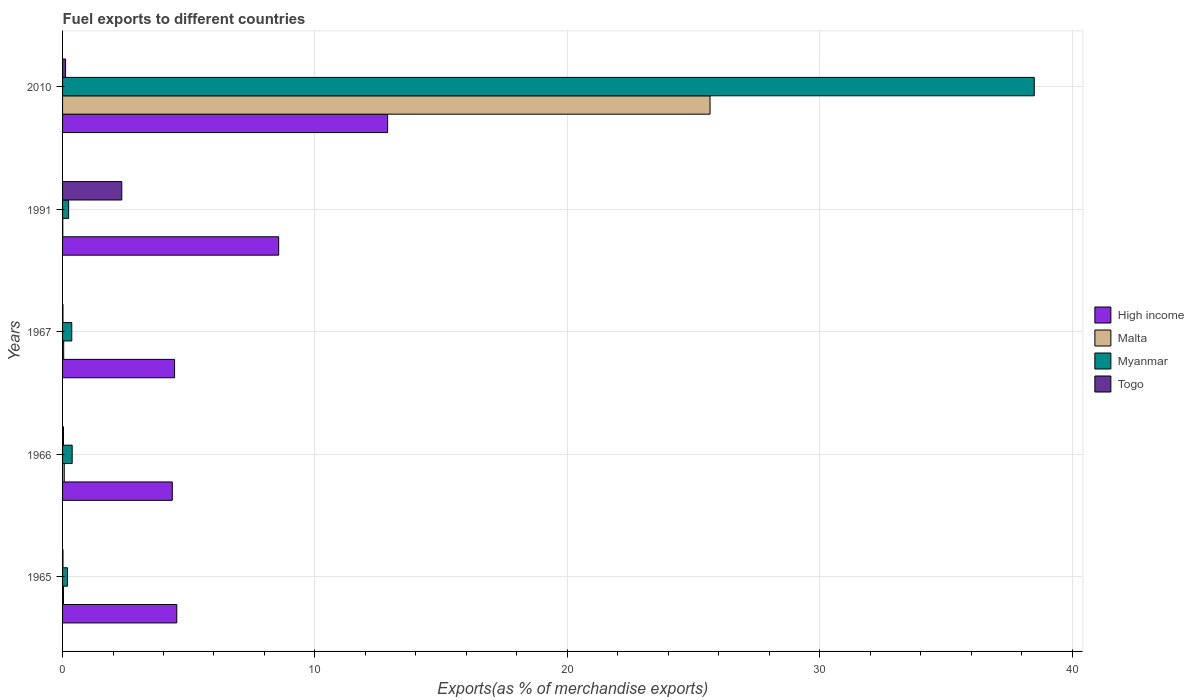How many groups of bars are there?
Offer a terse response. 5. Are the number of bars per tick equal to the number of legend labels?
Provide a short and direct response. Yes. How many bars are there on the 4th tick from the bottom?
Ensure brevity in your answer.  4. What is the label of the 1st group of bars from the top?
Provide a short and direct response. 2010. In how many cases, is the number of bars for a given year not equal to the number of legend labels?
Keep it short and to the point. 0. What is the percentage of exports to different countries in Togo in 2010?
Offer a terse response. 0.12. Across all years, what is the maximum percentage of exports to different countries in Togo?
Offer a terse response. 2.35. Across all years, what is the minimum percentage of exports to different countries in High income?
Make the answer very short. 4.35. In which year was the percentage of exports to different countries in Malta maximum?
Keep it short and to the point. 2010. What is the total percentage of exports to different countries in Malta in the graph?
Your answer should be compact. 25.81. What is the difference between the percentage of exports to different countries in High income in 1966 and that in 2010?
Your answer should be very brief. -8.53. What is the difference between the percentage of exports to different countries in High income in 1966 and the percentage of exports to different countries in Myanmar in 1967?
Offer a very short reply. 3.98. What is the average percentage of exports to different countries in Myanmar per year?
Give a very brief answer. 7.94. In the year 1967, what is the difference between the percentage of exports to different countries in Myanmar and percentage of exports to different countries in High income?
Your answer should be very brief. -4.07. What is the ratio of the percentage of exports to different countries in Myanmar in 1965 to that in 1966?
Ensure brevity in your answer.  0.52. Is the percentage of exports to different countries in Malta in 1965 less than that in 1966?
Offer a terse response. Yes. What is the difference between the highest and the second highest percentage of exports to different countries in Togo?
Offer a very short reply. 2.23. What is the difference between the highest and the lowest percentage of exports to different countries in High income?
Offer a very short reply. 8.53. Is the sum of the percentage of exports to different countries in Malta in 1966 and 1967 greater than the maximum percentage of exports to different countries in Togo across all years?
Offer a terse response. No. What does the 3rd bar from the top in 1965 represents?
Give a very brief answer. Malta. What does the 1st bar from the bottom in 1991 represents?
Your response must be concise. High income. Are all the bars in the graph horizontal?
Provide a short and direct response. Yes. What is the title of the graph?
Keep it short and to the point. Fuel exports to different countries. Does "Northern Mariana Islands" appear as one of the legend labels in the graph?
Keep it short and to the point. No. What is the label or title of the X-axis?
Your response must be concise. Exports(as % of merchandise exports). What is the Exports(as % of merchandise exports) in High income in 1965?
Provide a short and direct response. 4.53. What is the Exports(as % of merchandise exports) of Malta in 1965?
Your response must be concise. 0.04. What is the Exports(as % of merchandise exports) of Myanmar in 1965?
Your answer should be compact. 0.2. What is the Exports(as % of merchandise exports) of Togo in 1965?
Your answer should be compact. 0.02. What is the Exports(as % of merchandise exports) of High income in 1966?
Your response must be concise. 4.35. What is the Exports(as % of merchandise exports) in Malta in 1966?
Your answer should be compact. 0.07. What is the Exports(as % of merchandise exports) in Myanmar in 1966?
Ensure brevity in your answer.  0.38. What is the Exports(as % of merchandise exports) of Togo in 1966?
Keep it short and to the point. 0.04. What is the Exports(as % of merchandise exports) in High income in 1967?
Ensure brevity in your answer.  4.44. What is the Exports(as % of merchandise exports) of Malta in 1967?
Provide a succinct answer. 0.04. What is the Exports(as % of merchandise exports) of Myanmar in 1967?
Your answer should be compact. 0.36. What is the Exports(as % of merchandise exports) of Togo in 1967?
Give a very brief answer. 0.02. What is the Exports(as % of merchandise exports) of High income in 1991?
Make the answer very short. 8.56. What is the Exports(as % of merchandise exports) in Malta in 1991?
Your answer should be compact. 0.01. What is the Exports(as % of merchandise exports) of Myanmar in 1991?
Provide a succinct answer. 0.24. What is the Exports(as % of merchandise exports) of Togo in 1991?
Your response must be concise. 2.35. What is the Exports(as % of merchandise exports) of High income in 2010?
Provide a short and direct response. 12.88. What is the Exports(as % of merchandise exports) in Malta in 2010?
Your answer should be very brief. 25.66. What is the Exports(as % of merchandise exports) of Myanmar in 2010?
Offer a terse response. 38.5. What is the Exports(as % of merchandise exports) of Togo in 2010?
Offer a terse response. 0.12. Across all years, what is the maximum Exports(as % of merchandise exports) of High income?
Provide a short and direct response. 12.88. Across all years, what is the maximum Exports(as % of merchandise exports) of Malta?
Your answer should be very brief. 25.66. Across all years, what is the maximum Exports(as % of merchandise exports) of Myanmar?
Your answer should be very brief. 38.5. Across all years, what is the maximum Exports(as % of merchandise exports) in Togo?
Make the answer very short. 2.35. Across all years, what is the minimum Exports(as % of merchandise exports) in High income?
Offer a very short reply. 4.35. Across all years, what is the minimum Exports(as % of merchandise exports) of Malta?
Provide a succinct answer. 0.01. Across all years, what is the minimum Exports(as % of merchandise exports) in Myanmar?
Give a very brief answer. 0.2. Across all years, what is the minimum Exports(as % of merchandise exports) of Togo?
Offer a very short reply. 0.02. What is the total Exports(as % of merchandise exports) in High income in the graph?
Offer a terse response. 34.76. What is the total Exports(as % of merchandise exports) of Malta in the graph?
Give a very brief answer. 25.81. What is the total Exports(as % of merchandise exports) in Myanmar in the graph?
Your answer should be compact. 39.69. What is the total Exports(as % of merchandise exports) in Togo in the graph?
Provide a succinct answer. 2.54. What is the difference between the Exports(as % of merchandise exports) in High income in 1965 and that in 1966?
Offer a terse response. 0.18. What is the difference between the Exports(as % of merchandise exports) of Malta in 1965 and that in 1966?
Ensure brevity in your answer.  -0.03. What is the difference between the Exports(as % of merchandise exports) of Myanmar in 1965 and that in 1966?
Your response must be concise. -0.18. What is the difference between the Exports(as % of merchandise exports) in Togo in 1965 and that in 1966?
Provide a short and direct response. -0.02. What is the difference between the Exports(as % of merchandise exports) of High income in 1965 and that in 1967?
Your answer should be compact. 0.09. What is the difference between the Exports(as % of merchandise exports) of Malta in 1965 and that in 1967?
Your answer should be compact. -0.01. What is the difference between the Exports(as % of merchandise exports) in Myanmar in 1965 and that in 1967?
Make the answer very short. -0.17. What is the difference between the Exports(as % of merchandise exports) in Togo in 1965 and that in 1967?
Ensure brevity in your answer.  0. What is the difference between the Exports(as % of merchandise exports) in High income in 1965 and that in 1991?
Make the answer very short. -4.04. What is the difference between the Exports(as % of merchandise exports) in Malta in 1965 and that in 1991?
Offer a terse response. 0.03. What is the difference between the Exports(as % of merchandise exports) in Myanmar in 1965 and that in 1991?
Offer a terse response. -0.04. What is the difference between the Exports(as % of merchandise exports) in Togo in 1965 and that in 1991?
Ensure brevity in your answer.  -2.33. What is the difference between the Exports(as % of merchandise exports) of High income in 1965 and that in 2010?
Your answer should be very brief. -8.35. What is the difference between the Exports(as % of merchandise exports) of Malta in 1965 and that in 2010?
Your answer should be very brief. -25.62. What is the difference between the Exports(as % of merchandise exports) in Myanmar in 1965 and that in 2010?
Provide a succinct answer. -38.31. What is the difference between the Exports(as % of merchandise exports) of Togo in 1965 and that in 2010?
Your response must be concise. -0.1. What is the difference between the Exports(as % of merchandise exports) in High income in 1966 and that in 1967?
Give a very brief answer. -0.09. What is the difference between the Exports(as % of merchandise exports) of Malta in 1966 and that in 1967?
Provide a succinct answer. 0.02. What is the difference between the Exports(as % of merchandise exports) in Myanmar in 1966 and that in 1967?
Ensure brevity in your answer.  0.02. What is the difference between the Exports(as % of merchandise exports) in Togo in 1966 and that in 1967?
Your answer should be very brief. 0.02. What is the difference between the Exports(as % of merchandise exports) of High income in 1966 and that in 1991?
Provide a short and direct response. -4.22. What is the difference between the Exports(as % of merchandise exports) of Malta in 1966 and that in 1991?
Keep it short and to the point. 0.06. What is the difference between the Exports(as % of merchandise exports) in Myanmar in 1966 and that in 1991?
Your response must be concise. 0.14. What is the difference between the Exports(as % of merchandise exports) in Togo in 1966 and that in 1991?
Your answer should be compact. -2.31. What is the difference between the Exports(as % of merchandise exports) of High income in 1966 and that in 2010?
Your response must be concise. -8.53. What is the difference between the Exports(as % of merchandise exports) in Malta in 1966 and that in 2010?
Your response must be concise. -25.59. What is the difference between the Exports(as % of merchandise exports) of Myanmar in 1966 and that in 2010?
Keep it short and to the point. -38.12. What is the difference between the Exports(as % of merchandise exports) of Togo in 1966 and that in 2010?
Provide a short and direct response. -0.08. What is the difference between the Exports(as % of merchandise exports) in High income in 1967 and that in 1991?
Your answer should be very brief. -4.13. What is the difference between the Exports(as % of merchandise exports) in Malta in 1967 and that in 1991?
Keep it short and to the point. 0.04. What is the difference between the Exports(as % of merchandise exports) in Myanmar in 1967 and that in 1991?
Offer a terse response. 0.12. What is the difference between the Exports(as % of merchandise exports) of Togo in 1967 and that in 1991?
Ensure brevity in your answer.  -2.33. What is the difference between the Exports(as % of merchandise exports) in High income in 1967 and that in 2010?
Offer a very short reply. -8.44. What is the difference between the Exports(as % of merchandise exports) of Malta in 1967 and that in 2010?
Ensure brevity in your answer.  -25.61. What is the difference between the Exports(as % of merchandise exports) in Myanmar in 1967 and that in 2010?
Make the answer very short. -38.14. What is the difference between the Exports(as % of merchandise exports) of Togo in 1967 and that in 2010?
Provide a short and direct response. -0.1. What is the difference between the Exports(as % of merchandise exports) of High income in 1991 and that in 2010?
Make the answer very short. -4.32. What is the difference between the Exports(as % of merchandise exports) in Malta in 1991 and that in 2010?
Ensure brevity in your answer.  -25.65. What is the difference between the Exports(as % of merchandise exports) in Myanmar in 1991 and that in 2010?
Provide a short and direct response. -38.26. What is the difference between the Exports(as % of merchandise exports) of Togo in 1991 and that in 2010?
Your response must be concise. 2.23. What is the difference between the Exports(as % of merchandise exports) in High income in 1965 and the Exports(as % of merchandise exports) in Malta in 1966?
Your response must be concise. 4.46. What is the difference between the Exports(as % of merchandise exports) in High income in 1965 and the Exports(as % of merchandise exports) in Myanmar in 1966?
Offer a very short reply. 4.15. What is the difference between the Exports(as % of merchandise exports) in High income in 1965 and the Exports(as % of merchandise exports) in Togo in 1966?
Give a very brief answer. 4.49. What is the difference between the Exports(as % of merchandise exports) in Malta in 1965 and the Exports(as % of merchandise exports) in Myanmar in 1966?
Your response must be concise. -0.35. What is the difference between the Exports(as % of merchandise exports) of Malta in 1965 and the Exports(as % of merchandise exports) of Togo in 1966?
Give a very brief answer. -0. What is the difference between the Exports(as % of merchandise exports) in Myanmar in 1965 and the Exports(as % of merchandise exports) in Togo in 1966?
Give a very brief answer. 0.16. What is the difference between the Exports(as % of merchandise exports) in High income in 1965 and the Exports(as % of merchandise exports) in Malta in 1967?
Your answer should be compact. 4.48. What is the difference between the Exports(as % of merchandise exports) of High income in 1965 and the Exports(as % of merchandise exports) of Myanmar in 1967?
Your response must be concise. 4.16. What is the difference between the Exports(as % of merchandise exports) of High income in 1965 and the Exports(as % of merchandise exports) of Togo in 1967?
Make the answer very short. 4.51. What is the difference between the Exports(as % of merchandise exports) of Malta in 1965 and the Exports(as % of merchandise exports) of Myanmar in 1967?
Offer a very short reply. -0.33. What is the difference between the Exports(as % of merchandise exports) in Malta in 1965 and the Exports(as % of merchandise exports) in Togo in 1967?
Offer a terse response. 0.02. What is the difference between the Exports(as % of merchandise exports) of Myanmar in 1965 and the Exports(as % of merchandise exports) of Togo in 1967?
Your response must be concise. 0.18. What is the difference between the Exports(as % of merchandise exports) of High income in 1965 and the Exports(as % of merchandise exports) of Malta in 1991?
Offer a very short reply. 4.52. What is the difference between the Exports(as % of merchandise exports) in High income in 1965 and the Exports(as % of merchandise exports) in Myanmar in 1991?
Ensure brevity in your answer.  4.29. What is the difference between the Exports(as % of merchandise exports) in High income in 1965 and the Exports(as % of merchandise exports) in Togo in 1991?
Your response must be concise. 2.18. What is the difference between the Exports(as % of merchandise exports) of Malta in 1965 and the Exports(as % of merchandise exports) of Myanmar in 1991?
Give a very brief answer. -0.2. What is the difference between the Exports(as % of merchandise exports) in Malta in 1965 and the Exports(as % of merchandise exports) in Togo in 1991?
Give a very brief answer. -2.31. What is the difference between the Exports(as % of merchandise exports) of Myanmar in 1965 and the Exports(as % of merchandise exports) of Togo in 1991?
Your answer should be compact. -2.15. What is the difference between the Exports(as % of merchandise exports) in High income in 1965 and the Exports(as % of merchandise exports) in Malta in 2010?
Provide a short and direct response. -21.13. What is the difference between the Exports(as % of merchandise exports) of High income in 1965 and the Exports(as % of merchandise exports) of Myanmar in 2010?
Your response must be concise. -33.98. What is the difference between the Exports(as % of merchandise exports) of High income in 1965 and the Exports(as % of merchandise exports) of Togo in 2010?
Make the answer very short. 4.41. What is the difference between the Exports(as % of merchandise exports) in Malta in 1965 and the Exports(as % of merchandise exports) in Myanmar in 2010?
Your response must be concise. -38.47. What is the difference between the Exports(as % of merchandise exports) of Malta in 1965 and the Exports(as % of merchandise exports) of Togo in 2010?
Your answer should be very brief. -0.08. What is the difference between the Exports(as % of merchandise exports) of Myanmar in 1965 and the Exports(as % of merchandise exports) of Togo in 2010?
Offer a very short reply. 0.08. What is the difference between the Exports(as % of merchandise exports) in High income in 1966 and the Exports(as % of merchandise exports) in Malta in 1967?
Give a very brief answer. 4.3. What is the difference between the Exports(as % of merchandise exports) in High income in 1966 and the Exports(as % of merchandise exports) in Myanmar in 1967?
Offer a terse response. 3.98. What is the difference between the Exports(as % of merchandise exports) of High income in 1966 and the Exports(as % of merchandise exports) of Togo in 1967?
Offer a very short reply. 4.33. What is the difference between the Exports(as % of merchandise exports) in Malta in 1966 and the Exports(as % of merchandise exports) in Myanmar in 1967?
Your answer should be very brief. -0.3. What is the difference between the Exports(as % of merchandise exports) in Malta in 1966 and the Exports(as % of merchandise exports) in Togo in 1967?
Make the answer very short. 0.05. What is the difference between the Exports(as % of merchandise exports) in Myanmar in 1966 and the Exports(as % of merchandise exports) in Togo in 1967?
Your response must be concise. 0.36. What is the difference between the Exports(as % of merchandise exports) in High income in 1966 and the Exports(as % of merchandise exports) in Malta in 1991?
Ensure brevity in your answer.  4.34. What is the difference between the Exports(as % of merchandise exports) of High income in 1966 and the Exports(as % of merchandise exports) of Myanmar in 1991?
Your answer should be compact. 4.11. What is the difference between the Exports(as % of merchandise exports) of High income in 1966 and the Exports(as % of merchandise exports) of Togo in 1991?
Your answer should be very brief. 2. What is the difference between the Exports(as % of merchandise exports) of Malta in 1966 and the Exports(as % of merchandise exports) of Myanmar in 1991?
Provide a short and direct response. -0.17. What is the difference between the Exports(as % of merchandise exports) of Malta in 1966 and the Exports(as % of merchandise exports) of Togo in 1991?
Your answer should be compact. -2.28. What is the difference between the Exports(as % of merchandise exports) in Myanmar in 1966 and the Exports(as % of merchandise exports) in Togo in 1991?
Keep it short and to the point. -1.97. What is the difference between the Exports(as % of merchandise exports) of High income in 1966 and the Exports(as % of merchandise exports) of Malta in 2010?
Keep it short and to the point. -21.31. What is the difference between the Exports(as % of merchandise exports) of High income in 1966 and the Exports(as % of merchandise exports) of Myanmar in 2010?
Ensure brevity in your answer.  -34.16. What is the difference between the Exports(as % of merchandise exports) of High income in 1966 and the Exports(as % of merchandise exports) of Togo in 2010?
Give a very brief answer. 4.23. What is the difference between the Exports(as % of merchandise exports) of Malta in 1966 and the Exports(as % of merchandise exports) of Myanmar in 2010?
Provide a succinct answer. -38.44. What is the difference between the Exports(as % of merchandise exports) of Malta in 1966 and the Exports(as % of merchandise exports) of Togo in 2010?
Your answer should be compact. -0.05. What is the difference between the Exports(as % of merchandise exports) of Myanmar in 1966 and the Exports(as % of merchandise exports) of Togo in 2010?
Keep it short and to the point. 0.26. What is the difference between the Exports(as % of merchandise exports) in High income in 1967 and the Exports(as % of merchandise exports) in Malta in 1991?
Offer a terse response. 4.43. What is the difference between the Exports(as % of merchandise exports) of High income in 1967 and the Exports(as % of merchandise exports) of Myanmar in 1991?
Provide a short and direct response. 4.2. What is the difference between the Exports(as % of merchandise exports) of High income in 1967 and the Exports(as % of merchandise exports) of Togo in 1991?
Your answer should be very brief. 2.09. What is the difference between the Exports(as % of merchandise exports) in Malta in 1967 and the Exports(as % of merchandise exports) in Myanmar in 1991?
Your answer should be compact. -0.2. What is the difference between the Exports(as % of merchandise exports) of Malta in 1967 and the Exports(as % of merchandise exports) of Togo in 1991?
Offer a terse response. -2.3. What is the difference between the Exports(as % of merchandise exports) of Myanmar in 1967 and the Exports(as % of merchandise exports) of Togo in 1991?
Make the answer very short. -1.98. What is the difference between the Exports(as % of merchandise exports) in High income in 1967 and the Exports(as % of merchandise exports) in Malta in 2010?
Offer a very short reply. -21.22. What is the difference between the Exports(as % of merchandise exports) of High income in 1967 and the Exports(as % of merchandise exports) of Myanmar in 2010?
Offer a terse response. -34.07. What is the difference between the Exports(as % of merchandise exports) of High income in 1967 and the Exports(as % of merchandise exports) of Togo in 2010?
Provide a short and direct response. 4.32. What is the difference between the Exports(as % of merchandise exports) in Malta in 1967 and the Exports(as % of merchandise exports) in Myanmar in 2010?
Your answer should be compact. -38.46. What is the difference between the Exports(as % of merchandise exports) in Malta in 1967 and the Exports(as % of merchandise exports) in Togo in 2010?
Provide a succinct answer. -0.07. What is the difference between the Exports(as % of merchandise exports) in Myanmar in 1967 and the Exports(as % of merchandise exports) in Togo in 2010?
Your answer should be compact. 0.25. What is the difference between the Exports(as % of merchandise exports) of High income in 1991 and the Exports(as % of merchandise exports) of Malta in 2010?
Offer a terse response. -17.09. What is the difference between the Exports(as % of merchandise exports) of High income in 1991 and the Exports(as % of merchandise exports) of Myanmar in 2010?
Your response must be concise. -29.94. What is the difference between the Exports(as % of merchandise exports) in High income in 1991 and the Exports(as % of merchandise exports) in Togo in 2010?
Provide a succinct answer. 8.44. What is the difference between the Exports(as % of merchandise exports) in Malta in 1991 and the Exports(as % of merchandise exports) in Myanmar in 2010?
Provide a succinct answer. -38.5. What is the difference between the Exports(as % of merchandise exports) of Malta in 1991 and the Exports(as % of merchandise exports) of Togo in 2010?
Offer a very short reply. -0.11. What is the difference between the Exports(as % of merchandise exports) in Myanmar in 1991 and the Exports(as % of merchandise exports) in Togo in 2010?
Make the answer very short. 0.12. What is the average Exports(as % of merchandise exports) of High income per year?
Keep it short and to the point. 6.95. What is the average Exports(as % of merchandise exports) in Malta per year?
Ensure brevity in your answer.  5.16. What is the average Exports(as % of merchandise exports) in Myanmar per year?
Your response must be concise. 7.94. What is the average Exports(as % of merchandise exports) in Togo per year?
Make the answer very short. 0.51. In the year 1965, what is the difference between the Exports(as % of merchandise exports) of High income and Exports(as % of merchandise exports) of Malta?
Keep it short and to the point. 4.49. In the year 1965, what is the difference between the Exports(as % of merchandise exports) of High income and Exports(as % of merchandise exports) of Myanmar?
Provide a succinct answer. 4.33. In the year 1965, what is the difference between the Exports(as % of merchandise exports) in High income and Exports(as % of merchandise exports) in Togo?
Ensure brevity in your answer.  4.51. In the year 1965, what is the difference between the Exports(as % of merchandise exports) of Malta and Exports(as % of merchandise exports) of Myanmar?
Provide a succinct answer. -0.16. In the year 1965, what is the difference between the Exports(as % of merchandise exports) in Malta and Exports(as % of merchandise exports) in Togo?
Make the answer very short. 0.02. In the year 1965, what is the difference between the Exports(as % of merchandise exports) of Myanmar and Exports(as % of merchandise exports) of Togo?
Give a very brief answer. 0.18. In the year 1966, what is the difference between the Exports(as % of merchandise exports) in High income and Exports(as % of merchandise exports) in Malta?
Your answer should be very brief. 4.28. In the year 1966, what is the difference between the Exports(as % of merchandise exports) of High income and Exports(as % of merchandise exports) of Myanmar?
Provide a short and direct response. 3.97. In the year 1966, what is the difference between the Exports(as % of merchandise exports) in High income and Exports(as % of merchandise exports) in Togo?
Ensure brevity in your answer.  4.31. In the year 1966, what is the difference between the Exports(as % of merchandise exports) in Malta and Exports(as % of merchandise exports) in Myanmar?
Make the answer very short. -0.31. In the year 1966, what is the difference between the Exports(as % of merchandise exports) of Malta and Exports(as % of merchandise exports) of Togo?
Offer a terse response. 0.03. In the year 1966, what is the difference between the Exports(as % of merchandise exports) of Myanmar and Exports(as % of merchandise exports) of Togo?
Keep it short and to the point. 0.34. In the year 1967, what is the difference between the Exports(as % of merchandise exports) of High income and Exports(as % of merchandise exports) of Malta?
Keep it short and to the point. 4.39. In the year 1967, what is the difference between the Exports(as % of merchandise exports) in High income and Exports(as % of merchandise exports) in Myanmar?
Your response must be concise. 4.07. In the year 1967, what is the difference between the Exports(as % of merchandise exports) of High income and Exports(as % of merchandise exports) of Togo?
Your response must be concise. 4.42. In the year 1967, what is the difference between the Exports(as % of merchandise exports) of Malta and Exports(as % of merchandise exports) of Myanmar?
Your answer should be compact. -0.32. In the year 1967, what is the difference between the Exports(as % of merchandise exports) of Malta and Exports(as % of merchandise exports) of Togo?
Provide a succinct answer. 0.03. In the year 1967, what is the difference between the Exports(as % of merchandise exports) in Myanmar and Exports(as % of merchandise exports) in Togo?
Your answer should be compact. 0.35. In the year 1991, what is the difference between the Exports(as % of merchandise exports) of High income and Exports(as % of merchandise exports) of Malta?
Make the answer very short. 8.56. In the year 1991, what is the difference between the Exports(as % of merchandise exports) of High income and Exports(as % of merchandise exports) of Myanmar?
Offer a terse response. 8.32. In the year 1991, what is the difference between the Exports(as % of merchandise exports) of High income and Exports(as % of merchandise exports) of Togo?
Your answer should be very brief. 6.22. In the year 1991, what is the difference between the Exports(as % of merchandise exports) in Malta and Exports(as % of merchandise exports) in Myanmar?
Keep it short and to the point. -0.23. In the year 1991, what is the difference between the Exports(as % of merchandise exports) in Malta and Exports(as % of merchandise exports) in Togo?
Your answer should be very brief. -2.34. In the year 1991, what is the difference between the Exports(as % of merchandise exports) in Myanmar and Exports(as % of merchandise exports) in Togo?
Provide a succinct answer. -2.11. In the year 2010, what is the difference between the Exports(as % of merchandise exports) in High income and Exports(as % of merchandise exports) in Malta?
Your answer should be compact. -12.78. In the year 2010, what is the difference between the Exports(as % of merchandise exports) in High income and Exports(as % of merchandise exports) in Myanmar?
Offer a terse response. -25.62. In the year 2010, what is the difference between the Exports(as % of merchandise exports) of High income and Exports(as % of merchandise exports) of Togo?
Offer a very short reply. 12.76. In the year 2010, what is the difference between the Exports(as % of merchandise exports) of Malta and Exports(as % of merchandise exports) of Myanmar?
Keep it short and to the point. -12.85. In the year 2010, what is the difference between the Exports(as % of merchandise exports) of Malta and Exports(as % of merchandise exports) of Togo?
Your response must be concise. 25.54. In the year 2010, what is the difference between the Exports(as % of merchandise exports) in Myanmar and Exports(as % of merchandise exports) in Togo?
Give a very brief answer. 38.38. What is the ratio of the Exports(as % of merchandise exports) in High income in 1965 to that in 1966?
Your answer should be compact. 1.04. What is the ratio of the Exports(as % of merchandise exports) of Malta in 1965 to that in 1966?
Provide a short and direct response. 0.52. What is the ratio of the Exports(as % of merchandise exports) of Myanmar in 1965 to that in 1966?
Provide a short and direct response. 0.52. What is the ratio of the Exports(as % of merchandise exports) of Togo in 1965 to that in 1966?
Keep it short and to the point. 0.44. What is the ratio of the Exports(as % of merchandise exports) in High income in 1965 to that in 1967?
Make the answer very short. 1.02. What is the ratio of the Exports(as % of merchandise exports) in Malta in 1965 to that in 1967?
Your response must be concise. 0.78. What is the ratio of the Exports(as % of merchandise exports) in Myanmar in 1965 to that in 1967?
Make the answer very short. 0.54. What is the ratio of the Exports(as % of merchandise exports) in Togo in 1965 to that in 1967?
Your answer should be compact. 1.03. What is the ratio of the Exports(as % of merchandise exports) of High income in 1965 to that in 1991?
Offer a very short reply. 0.53. What is the ratio of the Exports(as % of merchandise exports) in Malta in 1965 to that in 1991?
Offer a very short reply. 4.11. What is the ratio of the Exports(as % of merchandise exports) in Myanmar in 1965 to that in 1991?
Provide a short and direct response. 0.82. What is the ratio of the Exports(as % of merchandise exports) of Togo in 1965 to that in 1991?
Provide a succinct answer. 0.01. What is the ratio of the Exports(as % of merchandise exports) of High income in 1965 to that in 2010?
Your response must be concise. 0.35. What is the ratio of the Exports(as % of merchandise exports) in Malta in 1965 to that in 2010?
Keep it short and to the point. 0. What is the ratio of the Exports(as % of merchandise exports) in Myanmar in 1965 to that in 2010?
Your answer should be very brief. 0.01. What is the ratio of the Exports(as % of merchandise exports) in Togo in 1965 to that in 2010?
Offer a very short reply. 0.14. What is the ratio of the Exports(as % of merchandise exports) of High income in 1966 to that in 1967?
Offer a terse response. 0.98. What is the ratio of the Exports(as % of merchandise exports) in Malta in 1966 to that in 1967?
Offer a terse response. 1.5. What is the ratio of the Exports(as % of merchandise exports) of Myanmar in 1966 to that in 1967?
Provide a succinct answer. 1.05. What is the ratio of the Exports(as % of merchandise exports) in Togo in 1966 to that in 1967?
Offer a terse response. 2.32. What is the ratio of the Exports(as % of merchandise exports) of High income in 1966 to that in 1991?
Provide a short and direct response. 0.51. What is the ratio of the Exports(as % of merchandise exports) of Malta in 1966 to that in 1991?
Offer a terse response. 7.85. What is the ratio of the Exports(as % of merchandise exports) of Myanmar in 1966 to that in 1991?
Your answer should be compact. 1.59. What is the ratio of the Exports(as % of merchandise exports) in Togo in 1966 to that in 1991?
Your response must be concise. 0.02. What is the ratio of the Exports(as % of merchandise exports) of High income in 1966 to that in 2010?
Offer a very short reply. 0.34. What is the ratio of the Exports(as % of merchandise exports) of Malta in 1966 to that in 2010?
Offer a terse response. 0. What is the ratio of the Exports(as % of merchandise exports) in Myanmar in 1966 to that in 2010?
Keep it short and to the point. 0.01. What is the ratio of the Exports(as % of merchandise exports) of Togo in 1966 to that in 2010?
Provide a succinct answer. 0.31. What is the ratio of the Exports(as % of merchandise exports) of High income in 1967 to that in 1991?
Give a very brief answer. 0.52. What is the ratio of the Exports(as % of merchandise exports) of Malta in 1967 to that in 1991?
Keep it short and to the point. 5.24. What is the ratio of the Exports(as % of merchandise exports) of Myanmar in 1967 to that in 1991?
Provide a succinct answer. 1.52. What is the ratio of the Exports(as % of merchandise exports) in Togo in 1967 to that in 1991?
Provide a succinct answer. 0.01. What is the ratio of the Exports(as % of merchandise exports) in High income in 1967 to that in 2010?
Your response must be concise. 0.34. What is the ratio of the Exports(as % of merchandise exports) of Malta in 1967 to that in 2010?
Provide a short and direct response. 0. What is the ratio of the Exports(as % of merchandise exports) of Myanmar in 1967 to that in 2010?
Your answer should be compact. 0.01. What is the ratio of the Exports(as % of merchandise exports) of Togo in 1967 to that in 2010?
Provide a short and direct response. 0.13. What is the ratio of the Exports(as % of merchandise exports) of High income in 1991 to that in 2010?
Provide a short and direct response. 0.66. What is the ratio of the Exports(as % of merchandise exports) of Myanmar in 1991 to that in 2010?
Keep it short and to the point. 0.01. What is the ratio of the Exports(as % of merchandise exports) in Togo in 1991 to that in 2010?
Provide a succinct answer. 19.69. What is the difference between the highest and the second highest Exports(as % of merchandise exports) of High income?
Your response must be concise. 4.32. What is the difference between the highest and the second highest Exports(as % of merchandise exports) in Malta?
Offer a very short reply. 25.59. What is the difference between the highest and the second highest Exports(as % of merchandise exports) of Myanmar?
Offer a terse response. 38.12. What is the difference between the highest and the second highest Exports(as % of merchandise exports) in Togo?
Offer a very short reply. 2.23. What is the difference between the highest and the lowest Exports(as % of merchandise exports) of High income?
Provide a short and direct response. 8.53. What is the difference between the highest and the lowest Exports(as % of merchandise exports) in Malta?
Ensure brevity in your answer.  25.65. What is the difference between the highest and the lowest Exports(as % of merchandise exports) in Myanmar?
Keep it short and to the point. 38.31. What is the difference between the highest and the lowest Exports(as % of merchandise exports) of Togo?
Provide a succinct answer. 2.33. 